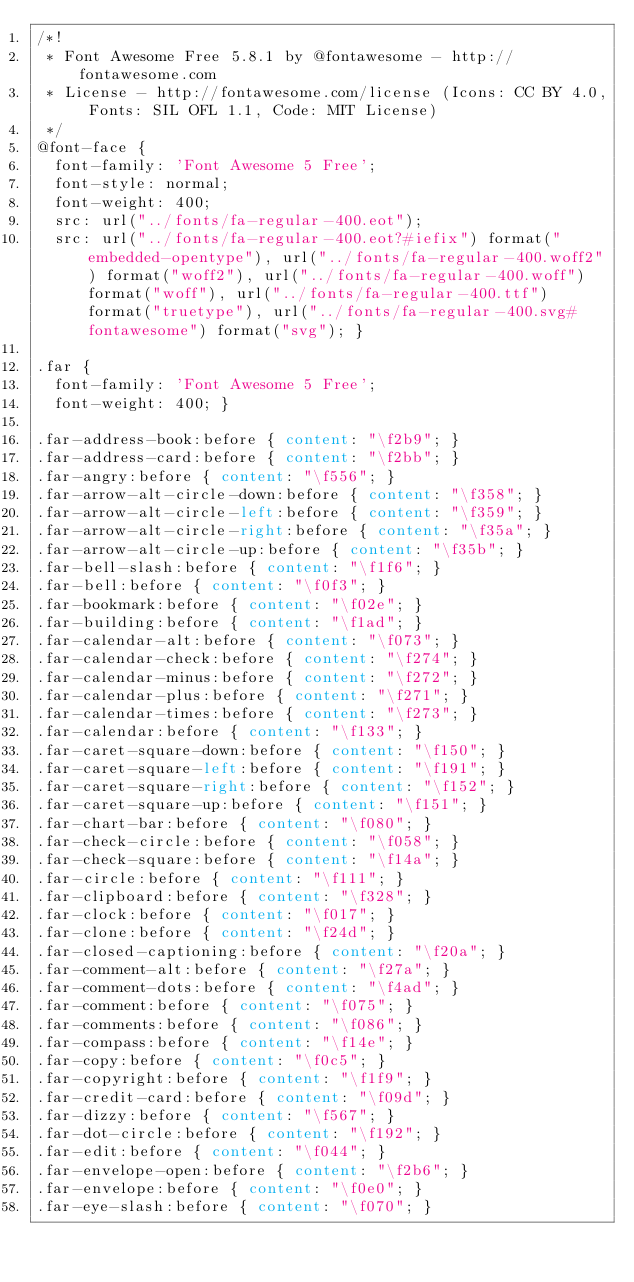<code> <loc_0><loc_0><loc_500><loc_500><_CSS_>/*!
 * Font Awesome Free 5.8.1 by @fontawesome - http://fontawesome.com
 * License - http://fontawesome.com/license (Icons: CC BY 4.0, Fonts: SIL OFL 1.1, Code: MIT License)
 */
@font-face {
  font-family: 'Font Awesome 5 Free';
  font-style: normal;
  font-weight: 400;
  src: url("../fonts/fa-regular-400.eot");
  src: url("../fonts/fa-regular-400.eot?#iefix") format("embedded-opentype"), url("../fonts/fa-regular-400.woff2") format("woff2"), url("../fonts/fa-regular-400.woff") format("woff"), url("../fonts/fa-regular-400.ttf") format("truetype"), url("../fonts/fa-regular-400.svg#fontawesome") format("svg"); }

.far {
  font-family: 'Font Awesome 5 Free';
  font-weight: 400; }

.far-address-book:before { content: "\f2b9"; }
.far-address-card:before { content: "\f2bb"; }
.far-angry:before { content: "\f556"; }
.far-arrow-alt-circle-down:before { content: "\f358"; }
.far-arrow-alt-circle-left:before { content: "\f359"; }
.far-arrow-alt-circle-right:before { content: "\f35a"; }
.far-arrow-alt-circle-up:before { content: "\f35b"; }
.far-bell-slash:before { content: "\f1f6"; }
.far-bell:before { content: "\f0f3"; }
.far-bookmark:before { content: "\f02e"; }
.far-building:before { content: "\f1ad"; }
.far-calendar-alt:before { content: "\f073"; }
.far-calendar-check:before { content: "\f274"; }
.far-calendar-minus:before { content: "\f272"; }
.far-calendar-plus:before { content: "\f271"; }
.far-calendar-times:before { content: "\f273"; }
.far-calendar:before { content: "\f133"; }
.far-caret-square-down:before { content: "\f150"; }
.far-caret-square-left:before { content: "\f191"; }
.far-caret-square-right:before { content: "\f152"; }
.far-caret-square-up:before { content: "\f151"; }
.far-chart-bar:before { content: "\f080"; }
.far-check-circle:before { content: "\f058"; }
.far-check-square:before { content: "\f14a"; }
.far-circle:before { content: "\f111"; }
.far-clipboard:before { content: "\f328"; }
.far-clock:before { content: "\f017"; }
.far-clone:before { content: "\f24d"; }
.far-closed-captioning:before { content: "\f20a"; }
.far-comment-alt:before { content: "\f27a"; }
.far-comment-dots:before { content: "\f4ad"; }
.far-comment:before { content: "\f075"; }
.far-comments:before { content: "\f086"; }
.far-compass:before { content: "\f14e"; }
.far-copy:before { content: "\f0c5"; }
.far-copyright:before { content: "\f1f9"; }
.far-credit-card:before { content: "\f09d"; }
.far-dizzy:before { content: "\f567"; }
.far-dot-circle:before { content: "\f192"; }
.far-edit:before { content: "\f044"; }
.far-envelope-open:before { content: "\f2b6"; }
.far-envelope:before { content: "\f0e0"; }
.far-eye-slash:before { content: "\f070"; }</code> 